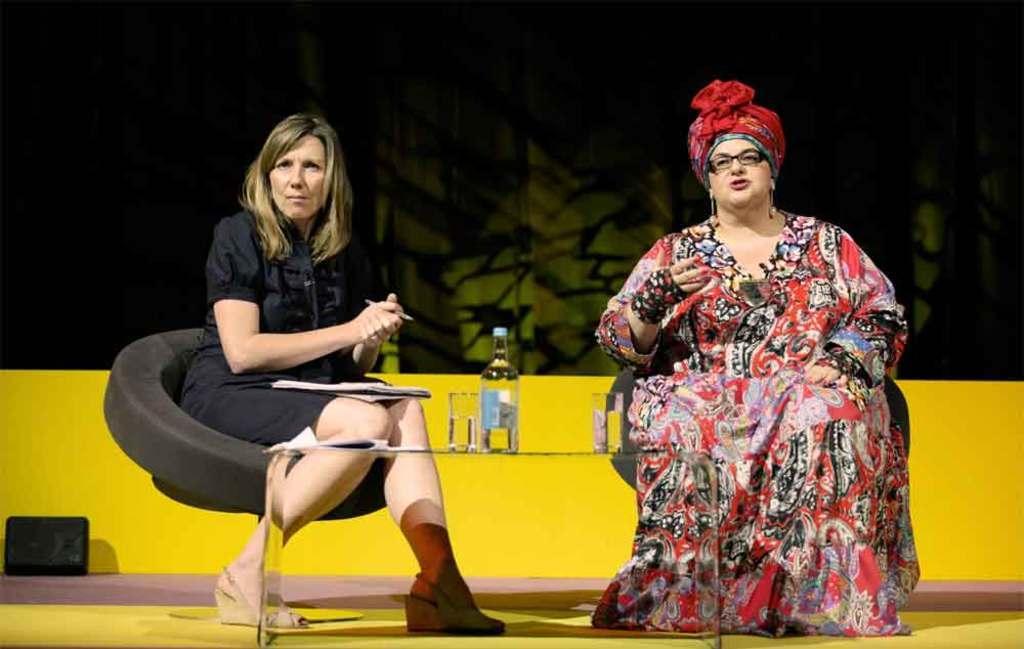In one or two sentences, can you explain what this image depicts? In this picture I can see 2 women who are sitting on chairs and I can see a table in front of them, on which there are 2 glasses and a bottle. In the background I can see the yellow color wall and on the left bottom of this picture I can see a black color thing. 